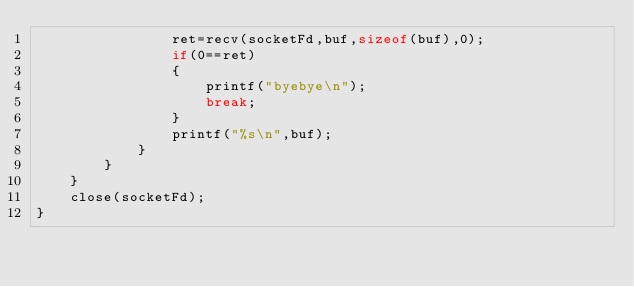Convert code to text. <code><loc_0><loc_0><loc_500><loc_500><_C_>                ret=recv(socketFd,buf,sizeof(buf),0);
                if(0==ret)
                {
                    printf("byebye\n");
                    break;
                }
                printf("%s\n",buf);
            }
        }
    }
    close(socketFd);
}
</code> 